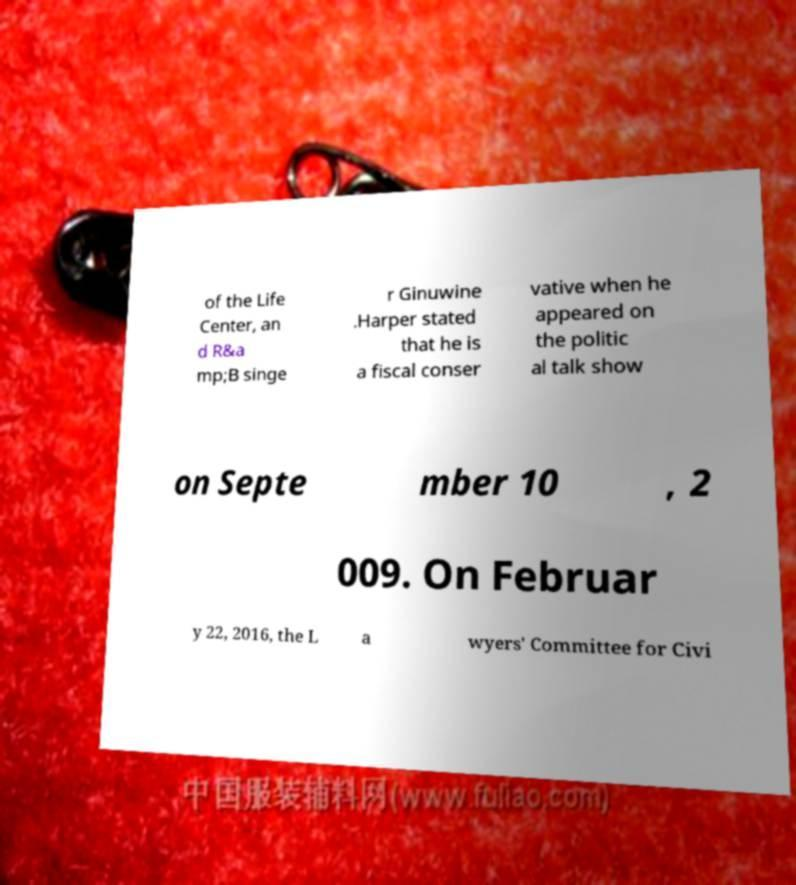Can you read and provide the text displayed in the image?This photo seems to have some interesting text. Can you extract and type it out for me? of the Life Center, an d R&a mp;B singe r Ginuwine .Harper stated that he is a fiscal conser vative when he appeared on the politic al talk show on Septe mber 10 , 2 009. On Februar y 22, 2016, the L a wyers' Committee for Civi 